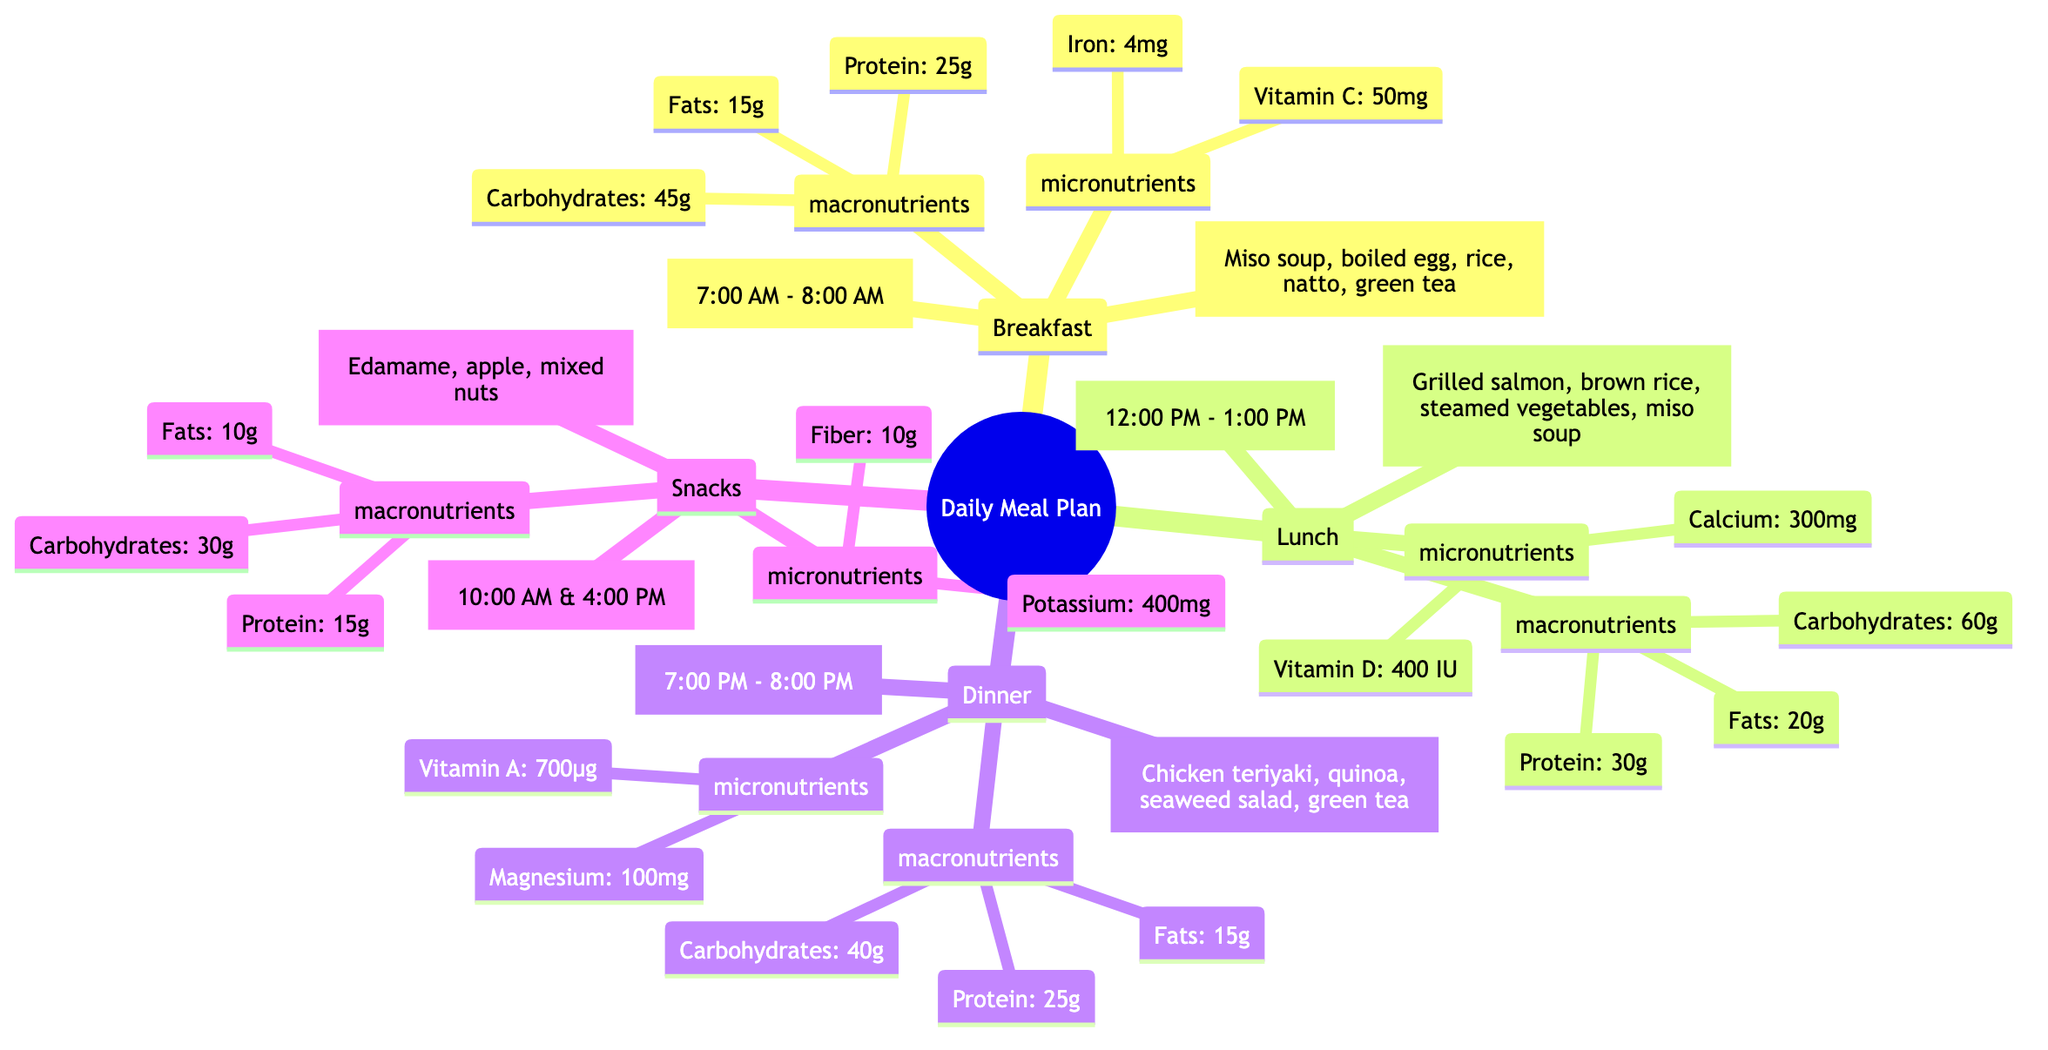What is the total protein intake from breakfast and lunch? To find the total protein intake from breakfast and lunch, we extract the protein amounts for each: Breakfast has 25g of protein and Lunch has 30g. We then add these values: 25g + 30g = 55g.
Answer: 55g What time is dinner served? The diagram directly indicates that dinner is served between 7:00 PM and 8:00 PM.
Answer: 7:00 PM - 8:00 PM How many micronutrients are listed for snacks? The micronutrients listed for snacks are Fiber and Potassium, totaling two micronutrients. Hence, we simply count them.
Answer: 2 What example meal is included in the lunch section? Based on the diagram, the example meal for lunch is Grilled salmon, brown rice, steamed vegetables, miso soup. This can be retrieved directly from the lunch node.
Answer: Grilled salmon, brown rice, steamed vegetables, miso soup Which meal has the highest carbohydrate content? The carbohydrate content can be compared across all meals: Breakfast has 45g, Lunch has 60g, Dinner has 40g, and Snacks have 30g. Lunch has the highest value at 60g.
Answer: Lunch What fat content is found in snacks? The snacks section in the diagram states that the fat content is 10g. This value can be found in the macronutrients section for snacks.
Answer: 10g What is the source of Vitamin D in lunch? The diagram lists lunch as containing two micronutrients: Calcium and Vitamin D. Since the source of Vitamin D is not specified in the diagram, we only know it is present without a specific source listed.
Answer: Not specified Which meal contains 50mg of Vitamin C? The diagram indicates that breakfast contains 50mg of Vitamin C under its micronutrient section. We locate this value under breakfast.
Answer: Breakfast 